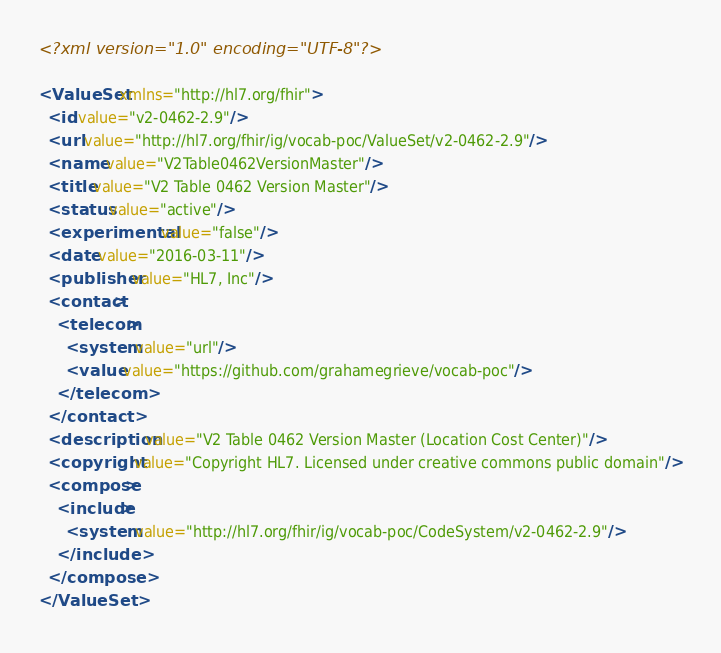Convert code to text. <code><loc_0><loc_0><loc_500><loc_500><_XML_><?xml version="1.0" encoding="UTF-8"?>

<ValueSet xmlns="http://hl7.org/fhir">
  <id value="v2-0462-2.9"/>
  <url value="http://hl7.org/fhir/ig/vocab-poc/ValueSet/v2-0462-2.9"/>
  <name value="V2Table0462VersionMaster"/>
  <title value="V2 Table 0462 Version Master"/>
  <status value="active"/>
  <experimental value="false"/>
  <date value="2016-03-11"/>
  <publisher value="HL7, Inc"/>
  <contact>
    <telecom>
      <system value="url"/>
      <value value="https://github.com/grahamegrieve/vocab-poc"/>
    </telecom>
  </contact>
  <description value="V2 Table 0462 Version Master (Location Cost Center)"/>
  <copyright value="Copyright HL7. Licensed under creative commons public domain"/>
  <compose>
    <include>
      <system value="http://hl7.org/fhir/ig/vocab-poc/CodeSystem/v2-0462-2.9"/>
    </include>
  </compose>
</ValueSet></code> 